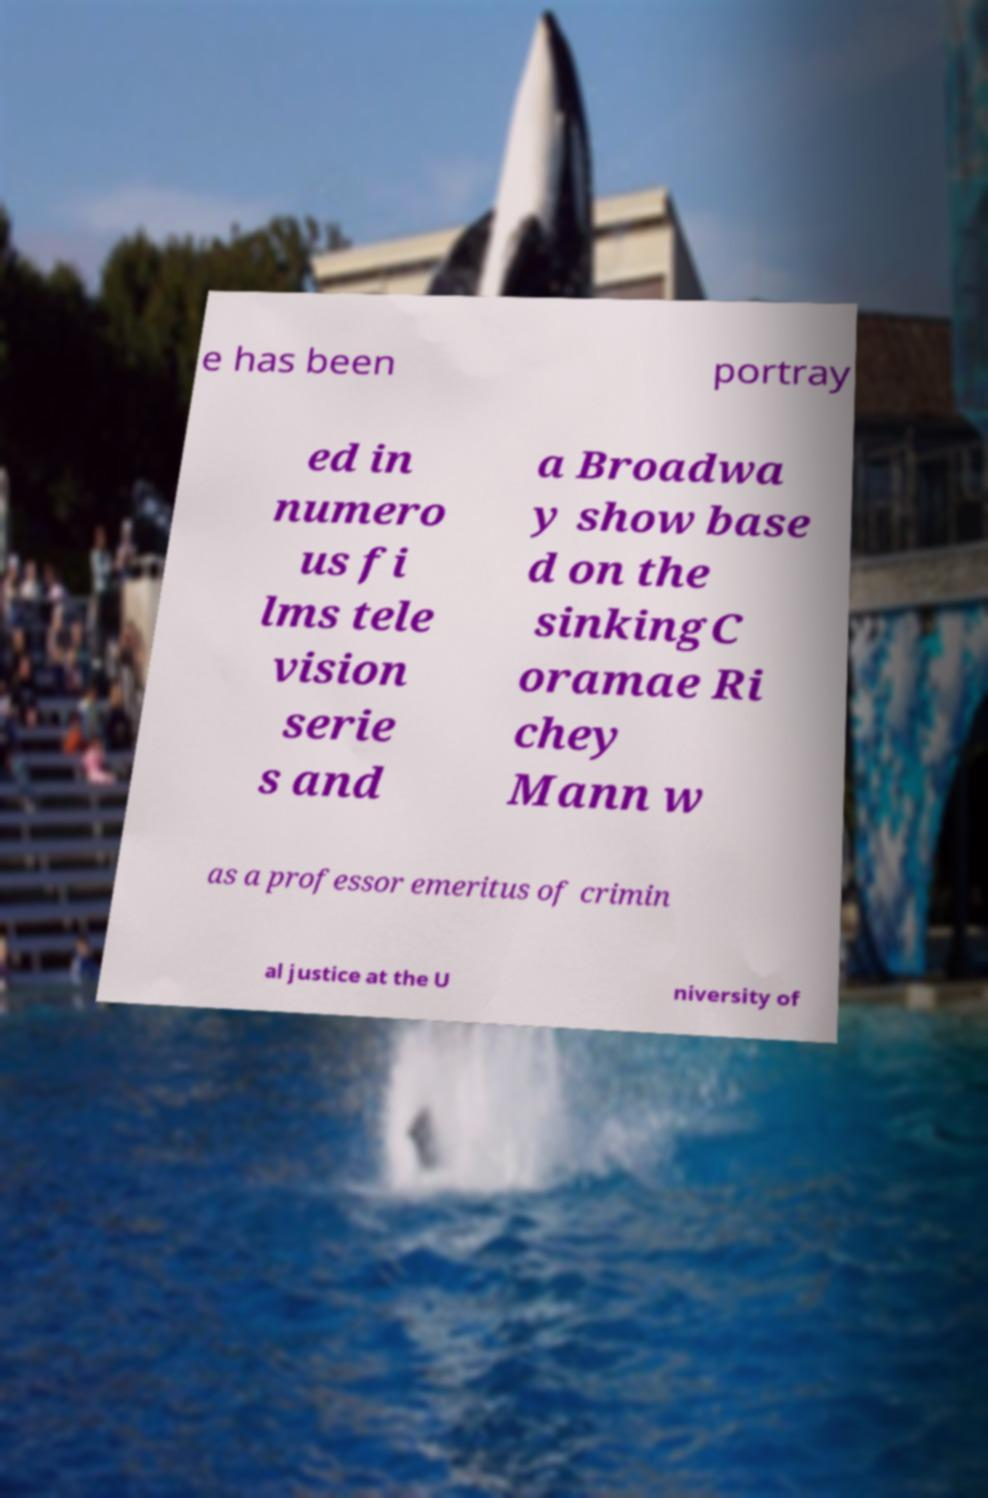Please read and relay the text visible in this image. What does it say? e has been portray ed in numero us fi lms tele vision serie s and a Broadwa y show base d on the sinkingC oramae Ri chey Mann w as a professor emeritus of crimin al justice at the U niversity of 